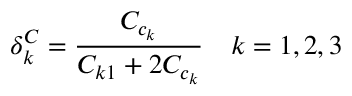<formula> <loc_0><loc_0><loc_500><loc_500>\delta _ { k } ^ { C } = \frac { C _ { c _ { k } } } { C _ { k 1 } + 2 C _ { c _ { k } } } \quad k = 1 , 2 , 3</formula> 